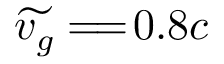Convert formula to latex. <formula><loc_0><loc_0><loc_500><loc_500>\widetilde { v _ { g } } = \, = \, 0 . 8 c</formula> 